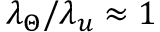<formula> <loc_0><loc_0><loc_500><loc_500>\lambda _ { \Theta } / \lambda _ { u } \approx 1</formula> 